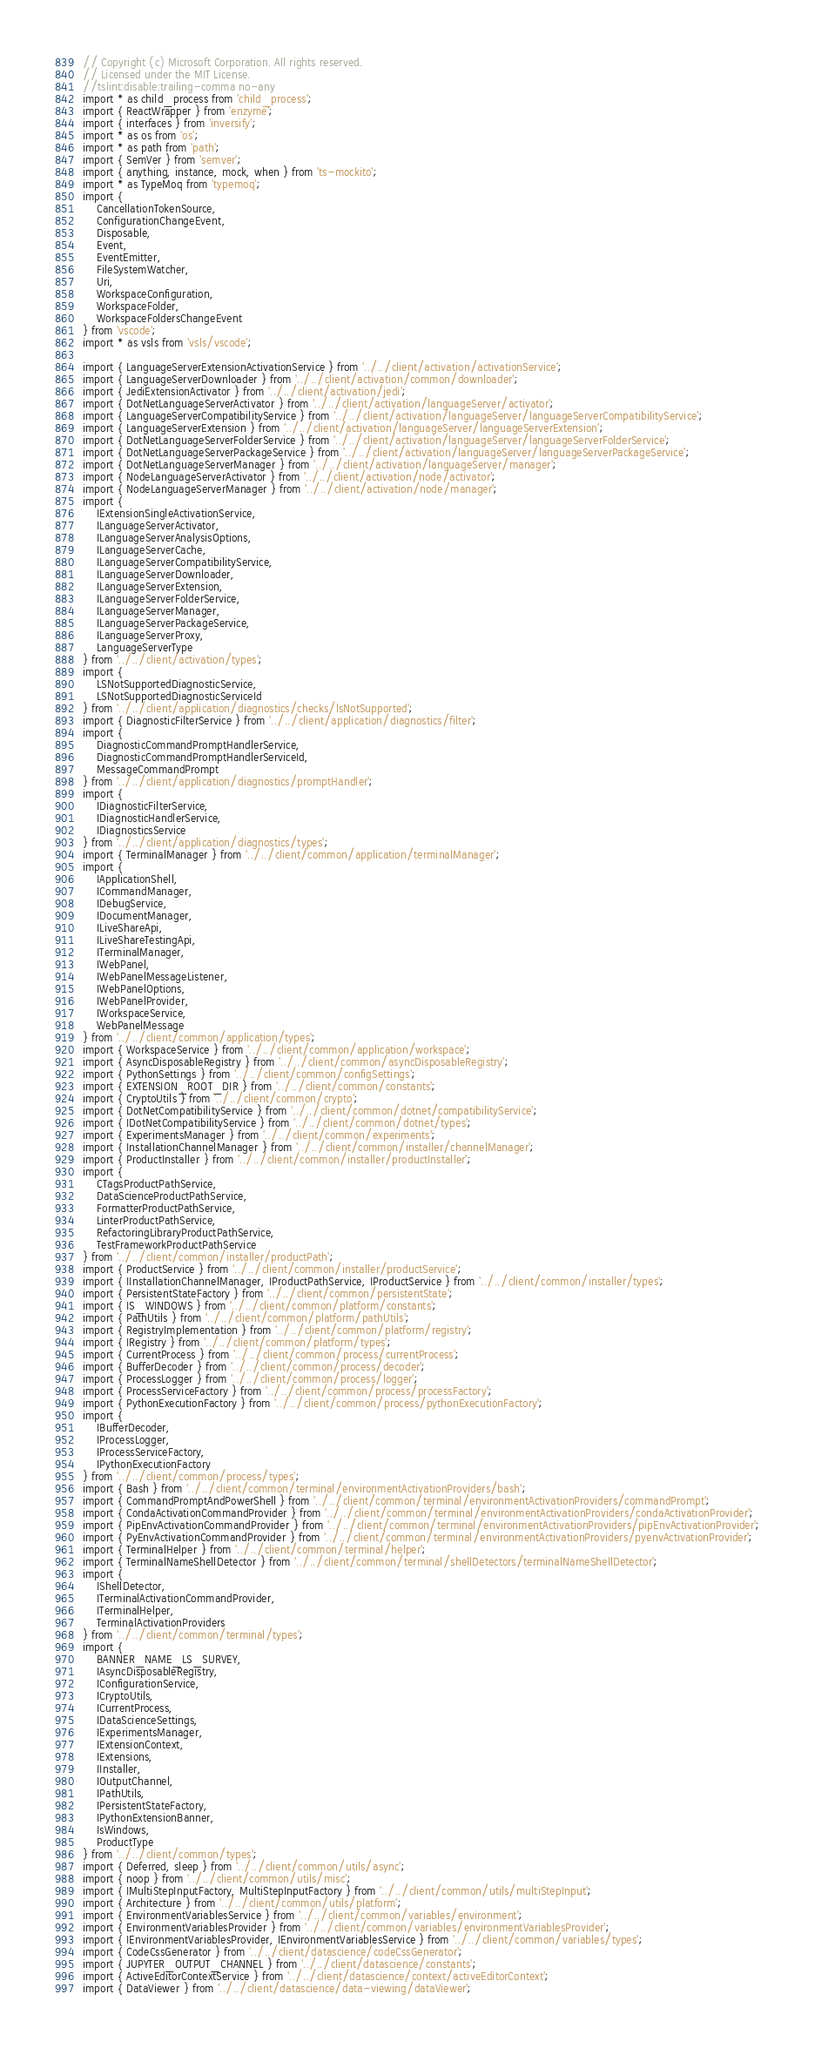Convert code to text. <code><loc_0><loc_0><loc_500><loc_500><_TypeScript_>// Copyright (c) Microsoft Corporation. All rights reserved.
// Licensed under the MIT License.
//tslint:disable:trailing-comma no-any
import * as child_process from 'child_process';
import { ReactWrapper } from 'enzyme';
import { interfaces } from 'inversify';
import * as os from 'os';
import * as path from 'path';
import { SemVer } from 'semver';
import { anything, instance, mock, when } from 'ts-mockito';
import * as TypeMoq from 'typemoq';
import {
    CancellationTokenSource,
    ConfigurationChangeEvent,
    Disposable,
    Event,
    EventEmitter,
    FileSystemWatcher,
    Uri,
    WorkspaceConfiguration,
    WorkspaceFolder,
    WorkspaceFoldersChangeEvent
} from 'vscode';
import * as vsls from 'vsls/vscode';

import { LanguageServerExtensionActivationService } from '../../client/activation/activationService';
import { LanguageServerDownloader } from '../../client/activation/common/downloader';
import { JediExtensionActivator } from '../../client/activation/jedi';
import { DotNetLanguageServerActivator } from '../../client/activation/languageServer/activator';
import { LanguageServerCompatibilityService } from '../../client/activation/languageServer/languageServerCompatibilityService';
import { LanguageServerExtension } from '../../client/activation/languageServer/languageServerExtension';
import { DotNetLanguageServerFolderService } from '../../client/activation/languageServer/languageServerFolderService';
import { DotNetLanguageServerPackageService } from '../../client/activation/languageServer/languageServerPackageService';
import { DotNetLanguageServerManager } from '../../client/activation/languageServer/manager';
import { NodeLanguageServerActivator } from '../../client/activation/node/activator';
import { NodeLanguageServerManager } from '../../client/activation/node/manager';
import {
    IExtensionSingleActivationService,
    ILanguageServerActivator,
    ILanguageServerAnalysisOptions,
    ILanguageServerCache,
    ILanguageServerCompatibilityService,
    ILanguageServerDownloader,
    ILanguageServerExtension,
    ILanguageServerFolderService,
    ILanguageServerManager,
    ILanguageServerPackageService,
    ILanguageServerProxy,
    LanguageServerType
} from '../../client/activation/types';
import {
    LSNotSupportedDiagnosticService,
    LSNotSupportedDiagnosticServiceId
} from '../../client/application/diagnostics/checks/lsNotSupported';
import { DiagnosticFilterService } from '../../client/application/diagnostics/filter';
import {
    DiagnosticCommandPromptHandlerService,
    DiagnosticCommandPromptHandlerServiceId,
    MessageCommandPrompt
} from '../../client/application/diagnostics/promptHandler';
import {
    IDiagnosticFilterService,
    IDiagnosticHandlerService,
    IDiagnosticsService
} from '../../client/application/diagnostics/types';
import { TerminalManager } from '../../client/common/application/terminalManager';
import {
    IApplicationShell,
    ICommandManager,
    IDebugService,
    IDocumentManager,
    ILiveShareApi,
    ILiveShareTestingApi,
    ITerminalManager,
    IWebPanel,
    IWebPanelMessageListener,
    IWebPanelOptions,
    IWebPanelProvider,
    IWorkspaceService,
    WebPanelMessage
} from '../../client/common/application/types';
import { WorkspaceService } from '../../client/common/application/workspace';
import { AsyncDisposableRegistry } from '../../client/common/asyncDisposableRegistry';
import { PythonSettings } from '../../client/common/configSettings';
import { EXTENSION_ROOT_DIR } from '../../client/common/constants';
import { CryptoUtils } from '../../client/common/crypto';
import { DotNetCompatibilityService } from '../../client/common/dotnet/compatibilityService';
import { IDotNetCompatibilityService } from '../../client/common/dotnet/types';
import { ExperimentsManager } from '../../client/common/experiments';
import { InstallationChannelManager } from '../../client/common/installer/channelManager';
import { ProductInstaller } from '../../client/common/installer/productInstaller';
import {
    CTagsProductPathService,
    DataScienceProductPathService,
    FormatterProductPathService,
    LinterProductPathService,
    RefactoringLibraryProductPathService,
    TestFrameworkProductPathService
} from '../../client/common/installer/productPath';
import { ProductService } from '../../client/common/installer/productService';
import { IInstallationChannelManager, IProductPathService, IProductService } from '../../client/common/installer/types';
import { PersistentStateFactory } from '../../client/common/persistentState';
import { IS_WINDOWS } from '../../client/common/platform/constants';
import { PathUtils } from '../../client/common/platform/pathUtils';
import { RegistryImplementation } from '../../client/common/platform/registry';
import { IRegistry } from '../../client/common/platform/types';
import { CurrentProcess } from '../../client/common/process/currentProcess';
import { BufferDecoder } from '../../client/common/process/decoder';
import { ProcessLogger } from '../../client/common/process/logger';
import { ProcessServiceFactory } from '../../client/common/process/processFactory';
import { PythonExecutionFactory } from '../../client/common/process/pythonExecutionFactory';
import {
    IBufferDecoder,
    IProcessLogger,
    IProcessServiceFactory,
    IPythonExecutionFactory
} from '../../client/common/process/types';
import { Bash } from '../../client/common/terminal/environmentActivationProviders/bash';
import { CommandPromptAndPowerShell } from '../../client/common/terminal/environmentActivationProviders/commandPrompt';
import { CondaActivationCommandProvider } from '../../client/common/terminal/environmentActivationProviders/condaActivationProvider';
import { PipEnvActivationCommandProvider } from '../../client/common/terminal/environmentActivationProviders/pipEnvActivationProvider';
import { PyEnvActivationCommandProvider } from '../../client/common/terminal/environmentActivationProviders/pyenvActivationProvider';
import { TerminalHelper } from '../../client/common/terminal/helper';
import { TerminalNameShellDetector } from '../../client/common/terminal/shellDetectors/terminalNameShellDetector';
import {
    IShellDetector,
    ITerminalActivationCommandProvider,
    ITerminalHelper,
    TerminalActivationProviders
} from '../../client/common/terminal/types';
import {
    BANNER_NAME_LS_SURVEY,
    IAsyncDisposableRegistry,
    IConfigurationService,
    ICryptoUtils,
    ICurrentProcess,
    IDataScienceSettings,
    IExperimentsManager,
    IExtensionContext,
    IExtensions,
    IInstaller,
    IOutputChannel,
    IPathUtils,
    IPersistentStateFactory,
    IPythonExtensionBanner,
    IsWindows,
    ProductType
} from '../../client/common/types';
import { Deferred, sleep } from '../../client/common/utils/async';
import { noop } from '../../client/common/utils/misc';
import { IMultiStepInputFactory, MultiStepInputFactory } from '../../client/common/utils/multiStepInput';
import { Architecture } from '../../client/common/utils/platform';
import { EnvironmentVariablesService } from '../../client/common/variables/environment';
import { EnvironmentVariablesProvider } from '../../client/common/variables/environmentVariablesProvider';
import { IEnvironmentVariablesProvider, IEnvironmentVariablesService } from '../../client/common/variables/types';
import { CodeCssGenerator } from '../../client/datascience/codeCssGenerator';
import { JUPYTER_OUTPUT_CHANNEL } from '../../client/datascience/constants';
import { ActiveEditorContextService } from '../../client/datascience/context/activeEditorContext';
import { DataViewer } from '../../client/datascience/data-viewing/dataViewer';</code> 